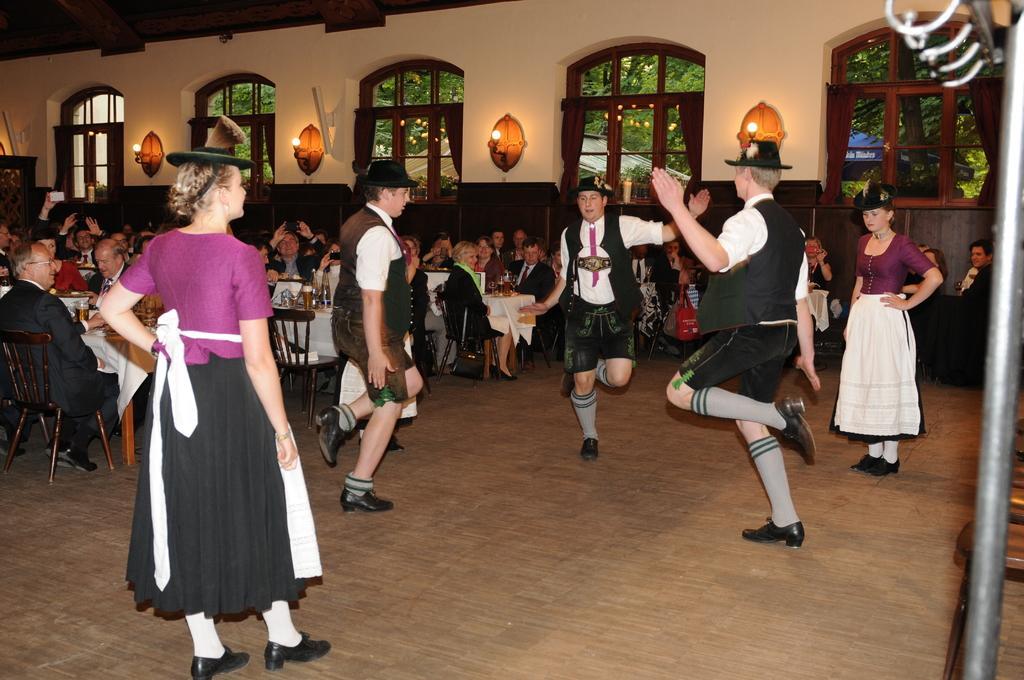Please provide a concise description of this image. In this picture we can see some people dancing on the floor and some people sitting on chairs. In front of the sitting people there are tables and on the tables there are some objects. Behind the people there is a wall with windows and lights. On the right side of the image there is an iron rod. Behind the windows there are trees and some objects. 